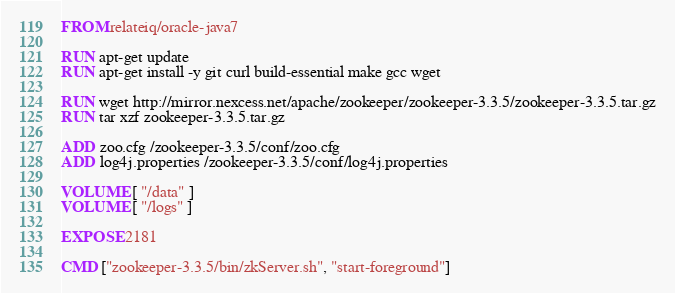<code> <loc_0><loc_0><loc_500><loc_500><_Dockerfile_>FROM relateiq/oracle-java7

RUN apt-get update
RUN apt-get install -y git curl build-essential make gcc wget

RUN wget http://mirror.nexcess.net/apache/zookeeper/zookeeper-3.3.5/zookeeper-3.3.5.tar.gz
RUN tar xzf zookeeper-3.3.5.tar.gz

ADD zoo.cfg /zookeeper-3.3.5/conf/zoo.cfg
ADD log4j.properties /zookeeper-3.3.5/conf/log4j.properties

VOLUME [ "/data" ]
VOLUME [ "/logs" ]

EXPOSE 2181

CMD ["zookeeper-3.3.5/bin/zkServer.sh", "start-foreground"]

</code> 